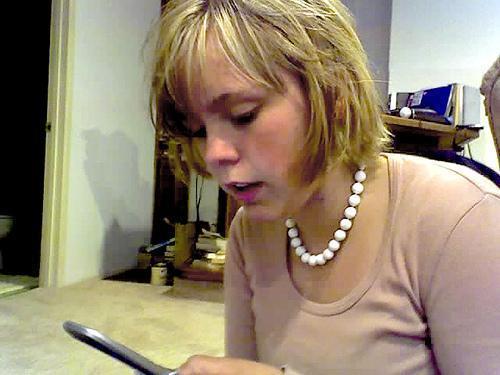How many people are there?
Give a very brief answer. 1. 